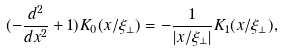<formula> <loc_0><loc_0><loc_500><loc_500>( - \frac { d ^ { 2 } } { d x ^ { 2 } } + 1 ) K _ { 0 } ( x / \xi _ { \perp } ) = - \frac { 1 } { | x / \xi _ { \perp } | } K _ { 1 } ( x / \xi _ { \perp } ) ,</formula> 